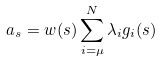Convert formula to latex. <formula><loc_0><loc_0><loc_500><loc_500>a _ { s } = w ( s ) \sum _ { i = \mu } ^ { N } \lambda _ { i } g _ { i } ( s )</formula> 